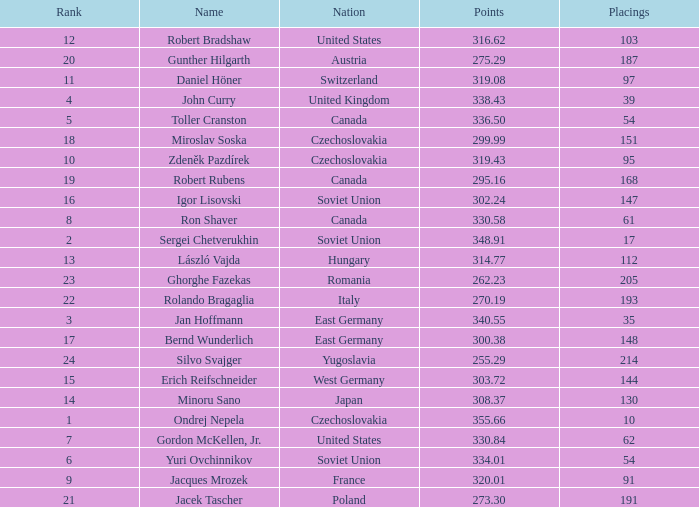How many Placings have Points smaller than 330.84, and a Name of silvo svajger? 1.0. 